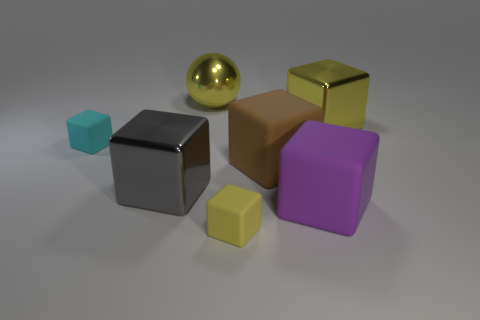Subtract all small cyan rubber cubes. How many cubes are left? 5 Subtract 2 cubes. How many cubes are left? 4 Subtract all gray blocks. How many blocks are left? 5 Subtract all gray cubes. Subtract all yellow cylinders. How many cubes are left? 5 Add 3 big brown matte cubes. How many objects exist? 10 Subtract all blocks. How many objects are left? 1 Subtract all gray objects. Subtract all big purple things. How many objects are left? 5 Add 7 shiny balls. How many shiny balls are left? 8 Add 2 large red rubber spheres. How many large red rubber spheres exist? 2 Subtract 0 cyan balls. How many objects are left? 7 